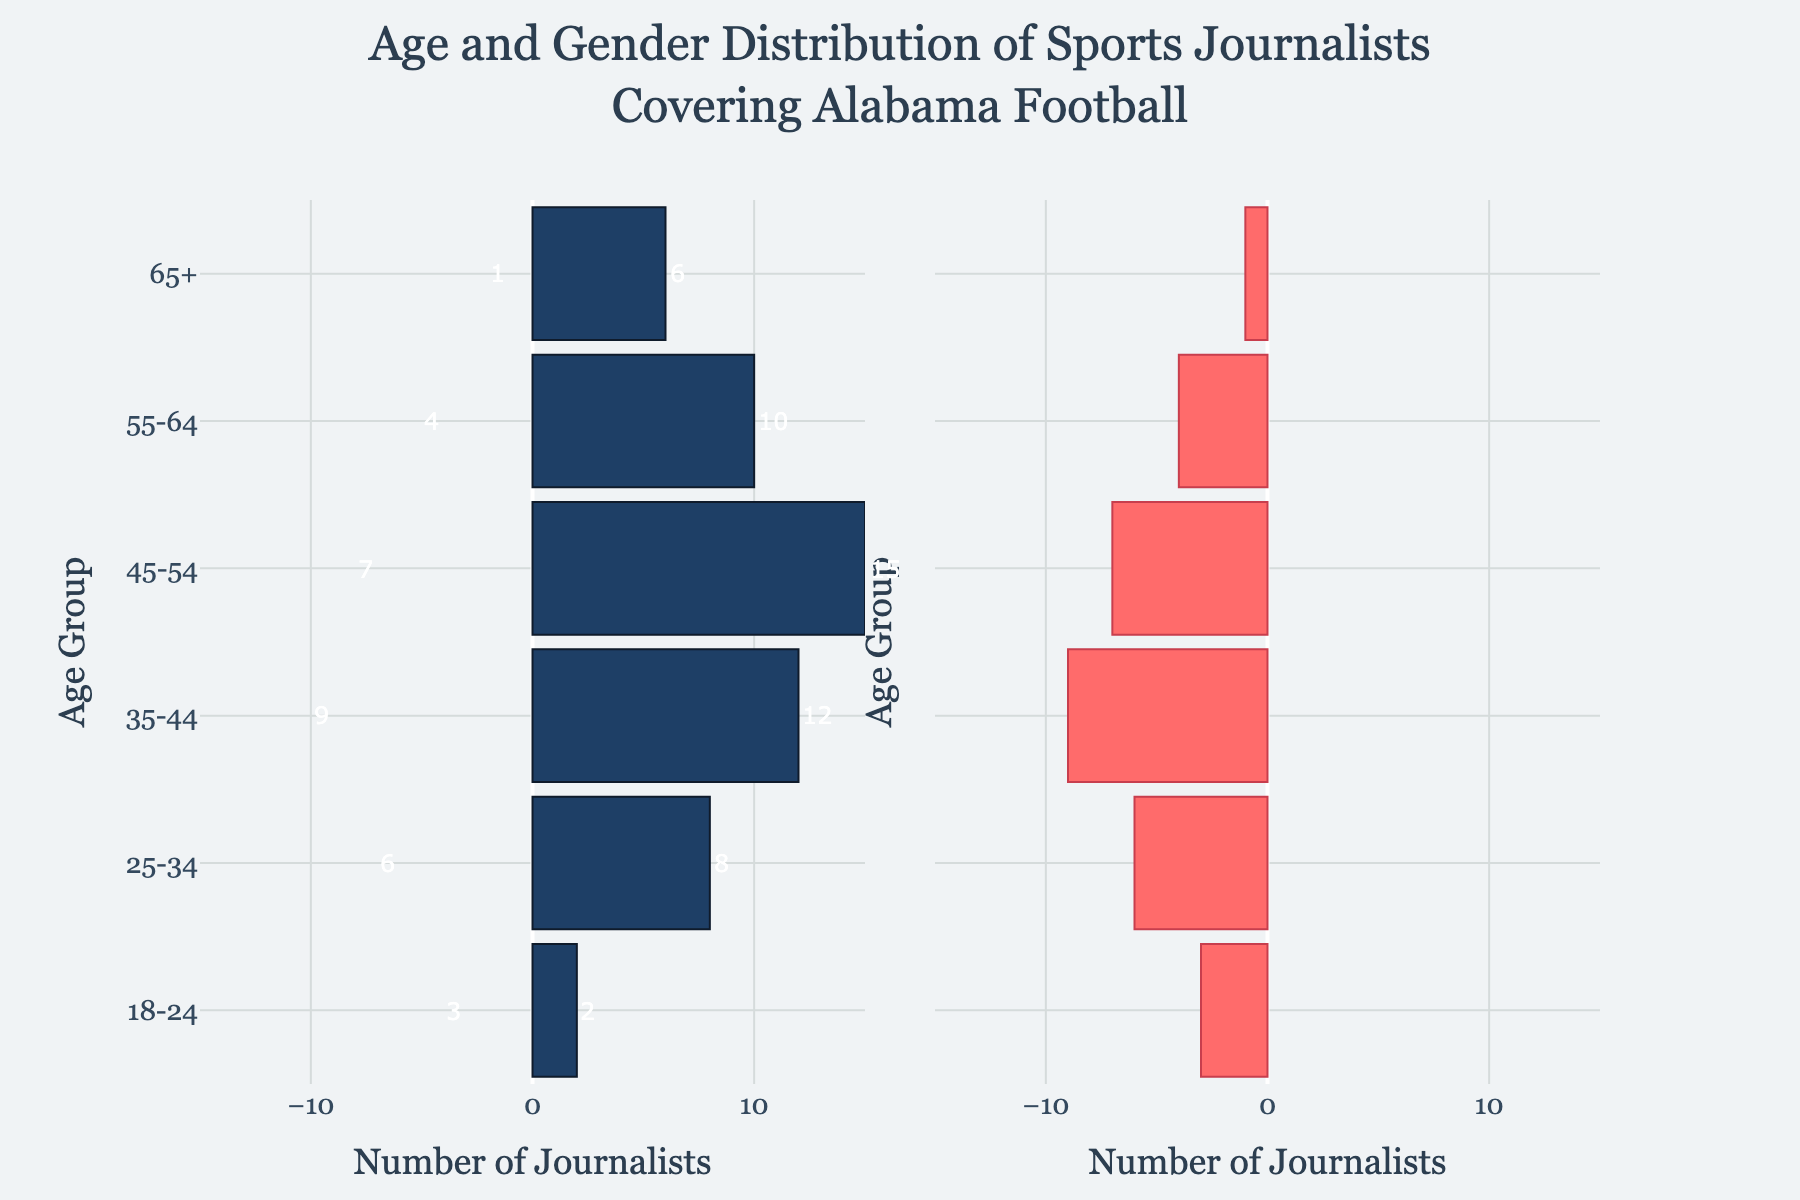What is the title of the chart? The title is displayed at the top of the chart. It reads "Age and Gender Distribution of Sports Journalists Covering Alabama Football".
Answer: Age and Gender Distribution of Sports Journalists Covering Alabama Football How many female journalists are in the 25-34 age group? Look at the 25-34 age group bar on the right side of the pyramid. The bar represents female journalists, and the value stated next to it is 6.
Answer: 6 Which age group has the highest number of male journalists? Identify the largest bar on the left side of the pyramid, which corresponds to male journalists. The bar for the 45-54 age group extends the furthest, indicating 15 male journalists.
Answer: 45-54 How many more male journalists are there compared to female journalists in the 45-54 age group? Male journalists (45-54 age group) = 15, Female journalists = 7. Subtract the female count from the male count: 15 - 7 = 8.
Answer: 8 What percentage of the total number of journalists in the 35-44 age group are female? Total journalists = 12 (male) + 9 (female) = 21. Percentage female = (9 / 21) * 100 ≈ 42.86%.
Answer: 42.86% What is the gender ratio (male to female) in the 55-64 age group? Number of male journalists in 55-64 age group = 10, number of female journalists = 4. Ratio of male to female = 10:4, which simplifies to 5:2.
Answer: 5:2 Which age group shows the smallest gender disparity in the number of journalists? Calculate the difference between male and female journalists for each age group. The smallest disparity is in the 18-24 age group (2 males and 3 females) with a difference of 1.
Answer: 18-24 How many journalists in total are in the 65+ age group? Sum the number of male and female journalists in the 65+ age group: 6 (male) + 1 (female) = 7.
Answer: 7 What is the total number of male journalists aged 25-44? Sum male journalists in 25-34 and 35-44 age groups: 8 (25-34) + 12 (35-44) = 20.
Answer: 20 Which gender has a higher average number of journalists per age group, and what is that average? Calculate average for males: (2 + 8 + 12 + 15 + 10 + 6) / 6 = 8.83; females: (3 + 6 + 9 + 7 + 4 + 1) / 6 = 5.33. Males have a higher average.
Answer: Males, 8.83 